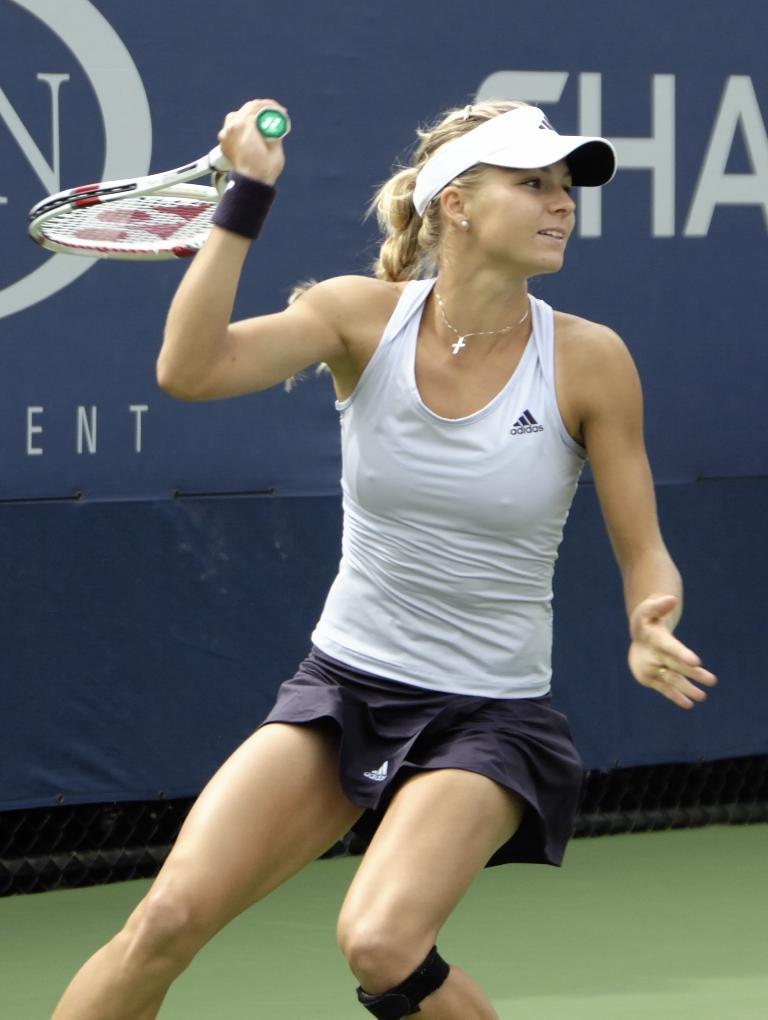Who is in the image? There is a woman in the image. What is the woman holding in the image? The woman is holding a tennis racket. What is the woman wearing in the image? The woman is wearing a tennis costume. What can be seen in the background of the image? There is a poster in the background of the image. What is written on the poster? There are letters written on the poster. What type of yoke is the woman using to carry her belongings in the image? There is no yoke present in the image, and the woman is not carrying any belongings. 